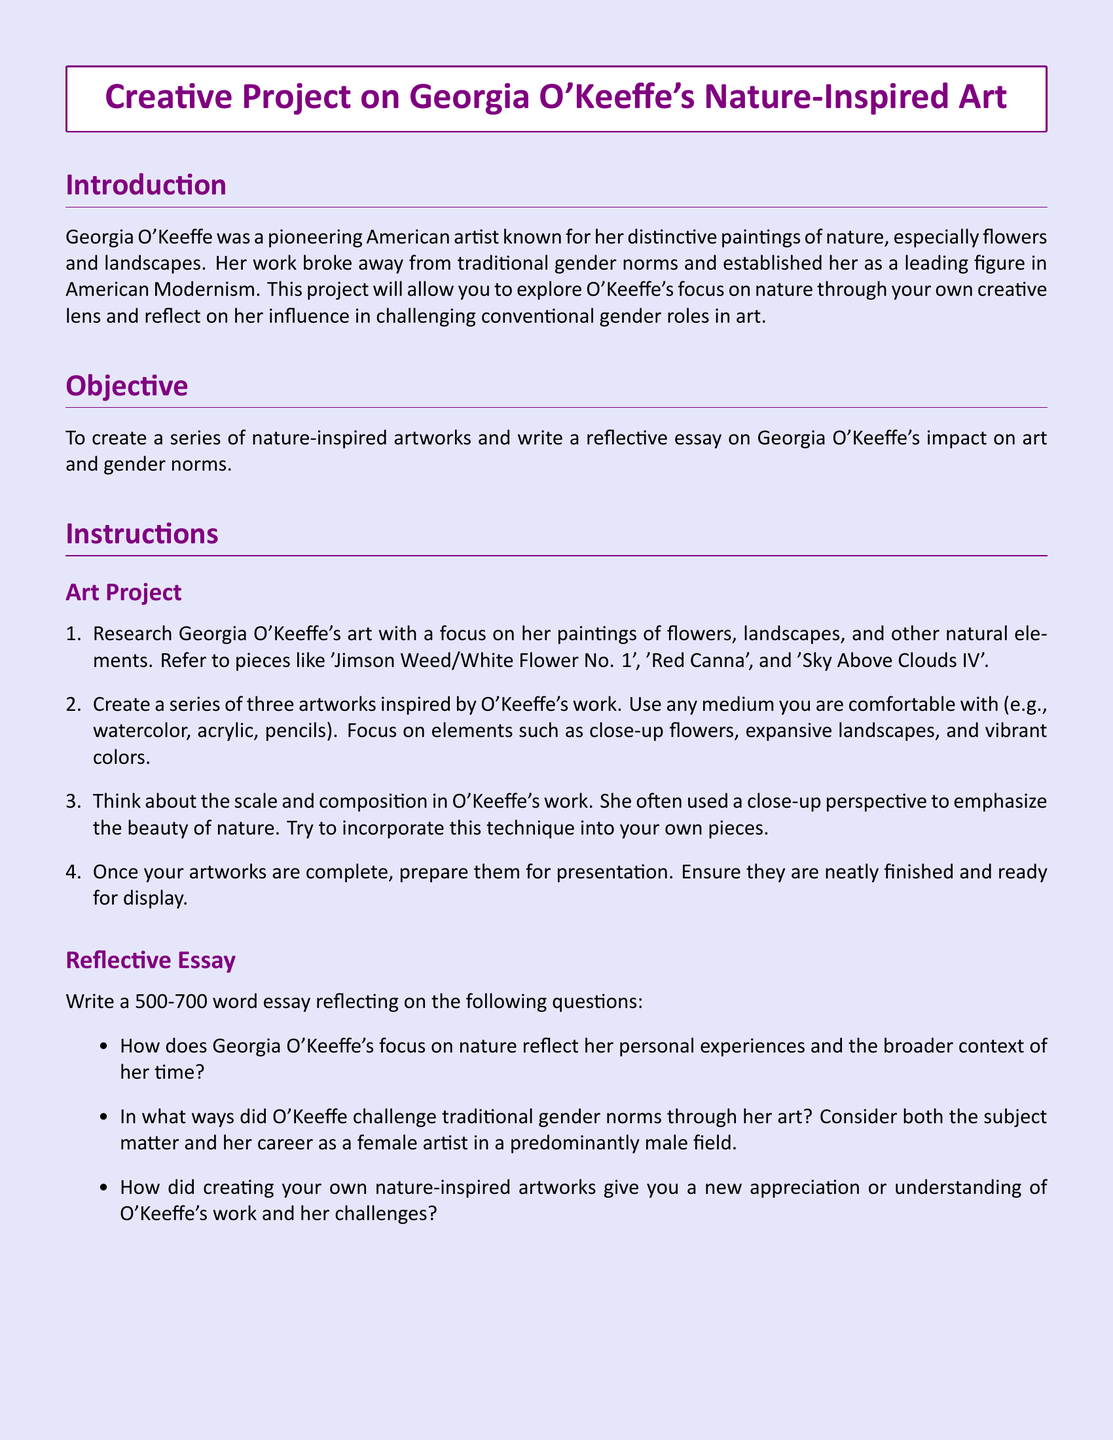What is the main focus of Georgia O'Keeffe's art? The document specifies that Georgia O'Keeffe is known for her distinctive paintings of nature, especially flowers and landscapes.
Answer: Nature, flowers, and landscapes How many artworks must students create for their project? The instructions state that students need to create a series of three artworks inspired by O'Keeffe's work.
Answer: Three artworks What is the word count requirement for the reflective essay? The essay instructions indicate that the reflective essay should be between 500-700 words.
Answer: 500-700 words What painting is referenced in the document as 'Jimson Weed/White Flower No. 1'? The document provides the title of the artwork as an example of O'Keeffe's work to research.
Answer: Jimson Weed/White Flower No. 1 Who authored the book "Georgia O'Keeffe: A Life"? The document lists Roxana Robinson as the author of the mentioned book.
Answer: Roxana Robinson In which year is the homework project due? The due date section specifies the project is due on October 28, 2023.
Answer: October 28, 2023 What evaluation criteria are used for the Art Project? The evaluation criteria for the Art Project are based on creativity, technique, and capturing O'Keeffe's nature-inspired themes.
Answer: Creativity, technique, nature-inspired themes Name a website listed as a resource for information on Georgia O'Keeffe. The document provides a URL for the Georgia O'Keeffe Official Website.
Answer: Georgia O'Keeffe Official Website What is the objective of the project? The document outlines that the objective is to create nature-inspired artworks and write a reflective essay on O'Keeffe's impact on art and gender norms.
Answer: Create nature-inspired artworks and write a reflective essay 